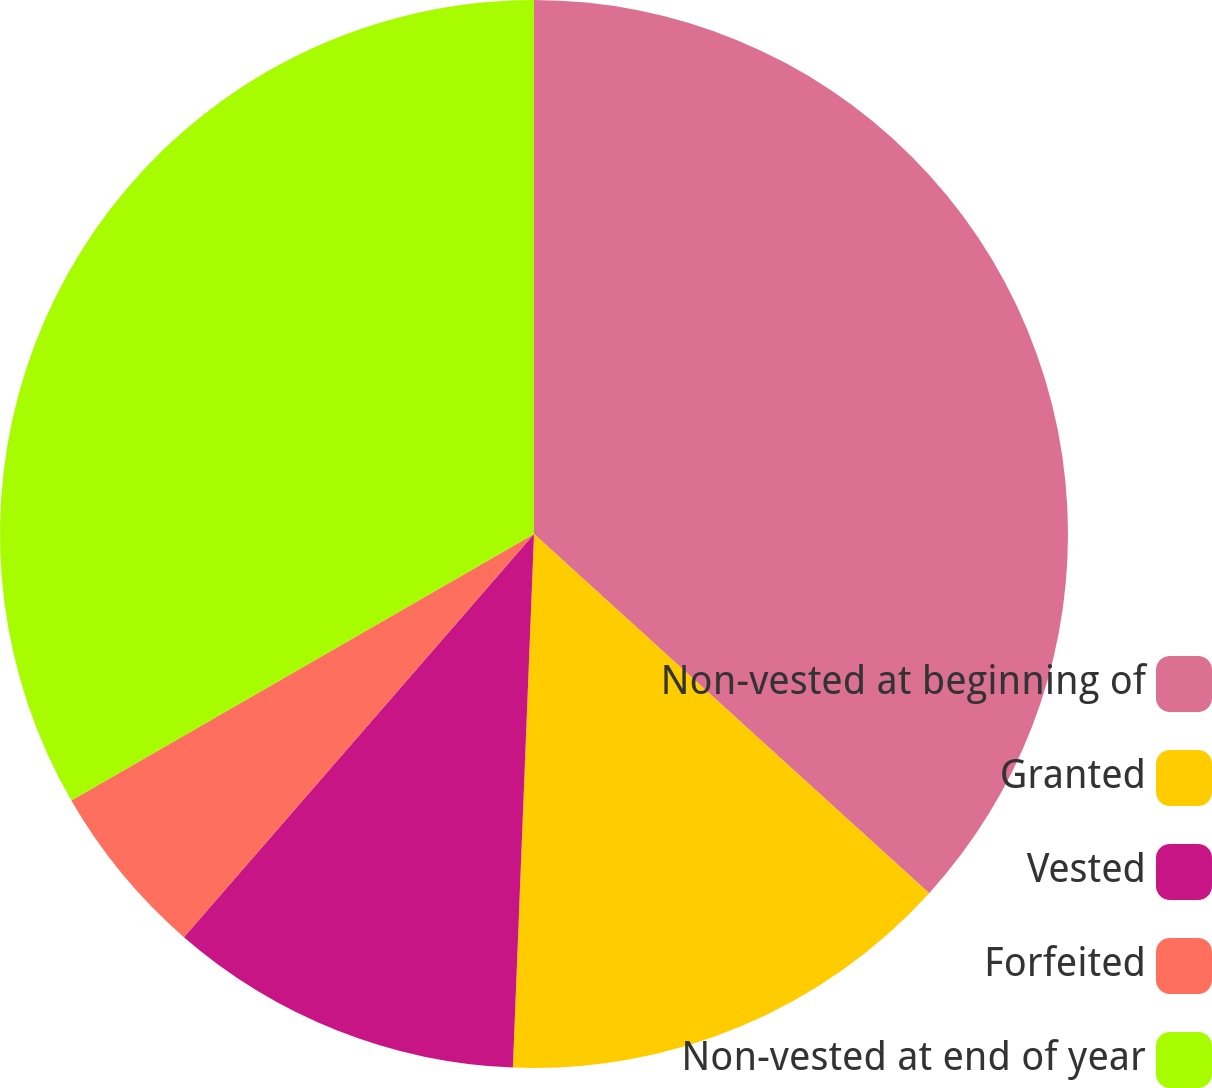Convert chart. <chart><loc_0><loc_0><loc_500><loc_500><pie_chart><fcel>Non-vested at beginning of<fcel>Granted<fcel>Vested<fcel>Forfeited<fcel>Non-vested at end of year<nl><fcel>36.74%<fcel>13.89%<fcel>10.75%<fcel>5.3%<fcel>33.32%<nl></chart> 